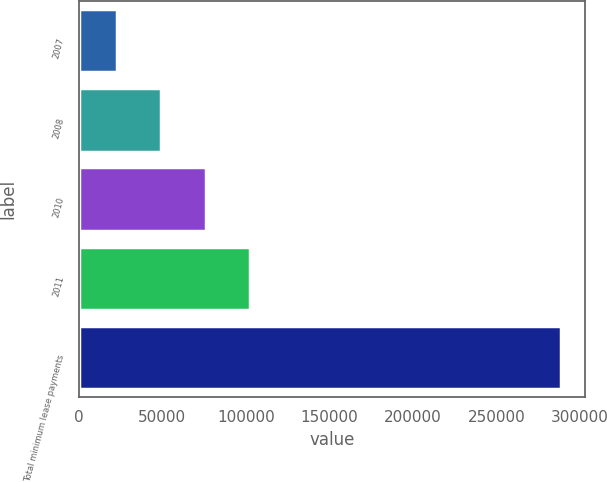Convert chart to OTSL. <chart><loc_0><loc_0><loc_500><loc_500><bar_chart><fcel>2007<fcel>2008<fcel>2010<fcel>2011<fcel>Total minimum lease payments<nl><fcel>22718<fcel>49328.5<fcel>75939<fcel>102550<fcel>288823<nl></chart> 